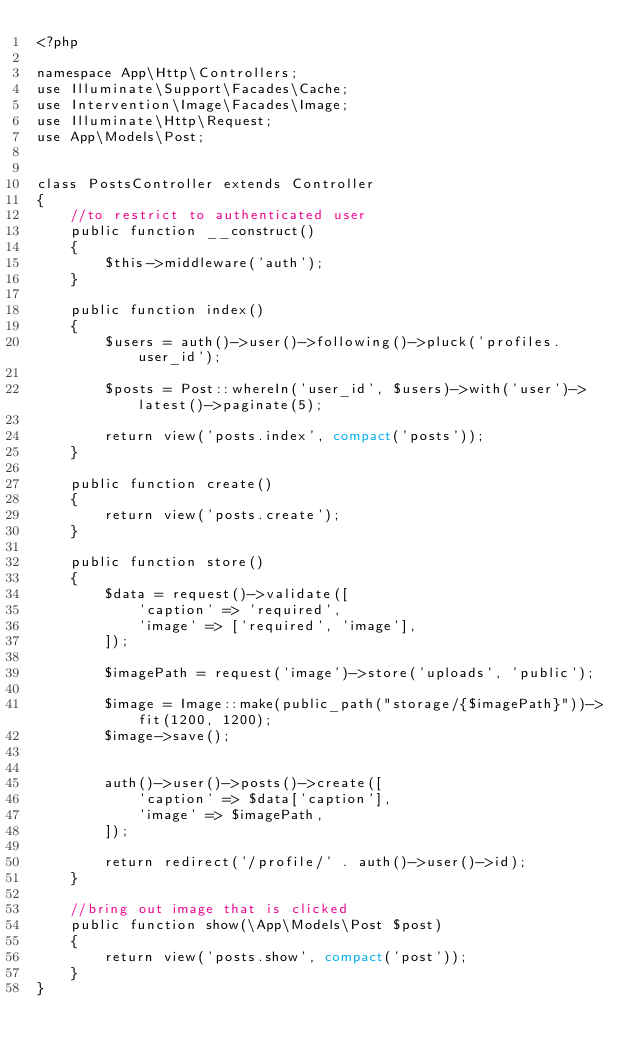<code> <loc_0><loc_0><loc_500><loc_500><_PHP_><?php

namespace App\Http\Controllers;
use Illuminate\Support\Facades\Cache;
use Intervention\Image\Facades\Image;
use Illuminate\Http\Request;
use App\Models\Post;


class PostsController extends Controller
{
    //to restrict to authenticated user
    public function __construct()
    {
        $this->middleware('auth');
    }

    public function index()
    {
        $users = auth()->user()->following()->pluck('profiles.user_id');

        $posts = Post::whereIn('user_id', $users)->with('user')->latest()->paginate(5);

        return view('posts.index', compact('posts'));
    }

    public function create()
    {
        return view('posts.create');
    }

    public function store()
    {
        $data = request()->validate([
            'caption' => 'required',
            'image' => ['required', 'image'],
        ]);

        $imagePath = request('image')->store('uploads', 'public');

        $image = Image::make(public_path("storage/{$imagePath}"))->fit(1200, 1200);
        $image->save();
        

        auth()->user()->posts()->create([
            'caption' => $data['caption'],
            'image' => $imagePath,
        ]);

        return redirect('/profile/' . auth()->user()->id);
    }
    
    //bring out image that is clicked
    public function show(\App\Models\Post $post)
    {
        return view('posts.show', compact('post'));
    }
}
</code> 